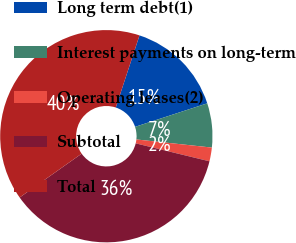Convert chart to OTSL. <chart><loc_0><loc_0><loc_500><loc_500><pie_chart><fcel>Long term debt(1)<fcel>Interest payments on long-term<fcel>Operating leases(2)<fcel>Subtotal<fcel>Total<nl><fcel>14.93%<fcel>6.72%<fcel>2.09%<fcel>36.41%<fcel>39.85%<nl></chart> 